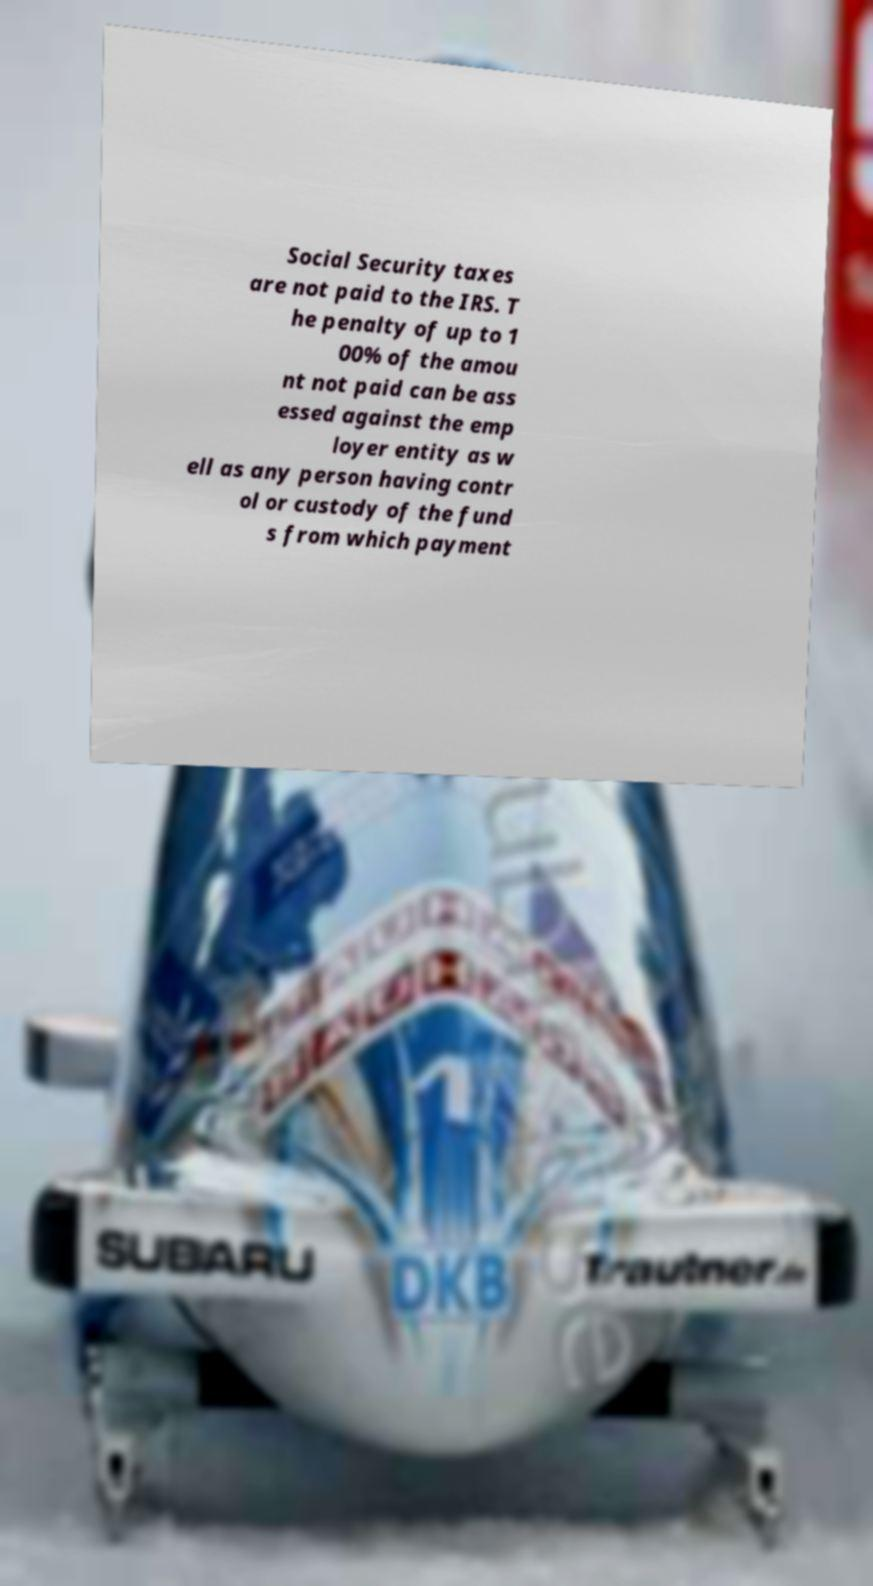I need the written content from this picture converted into text. Can you do that? Social Security taxes are not paid to the IRS. T he penalty of up to 1 00% of the amou nt not paid can be ass essed against the emp loyer entity as w ell as any person having contr ol or custody of the fund s from which payment 